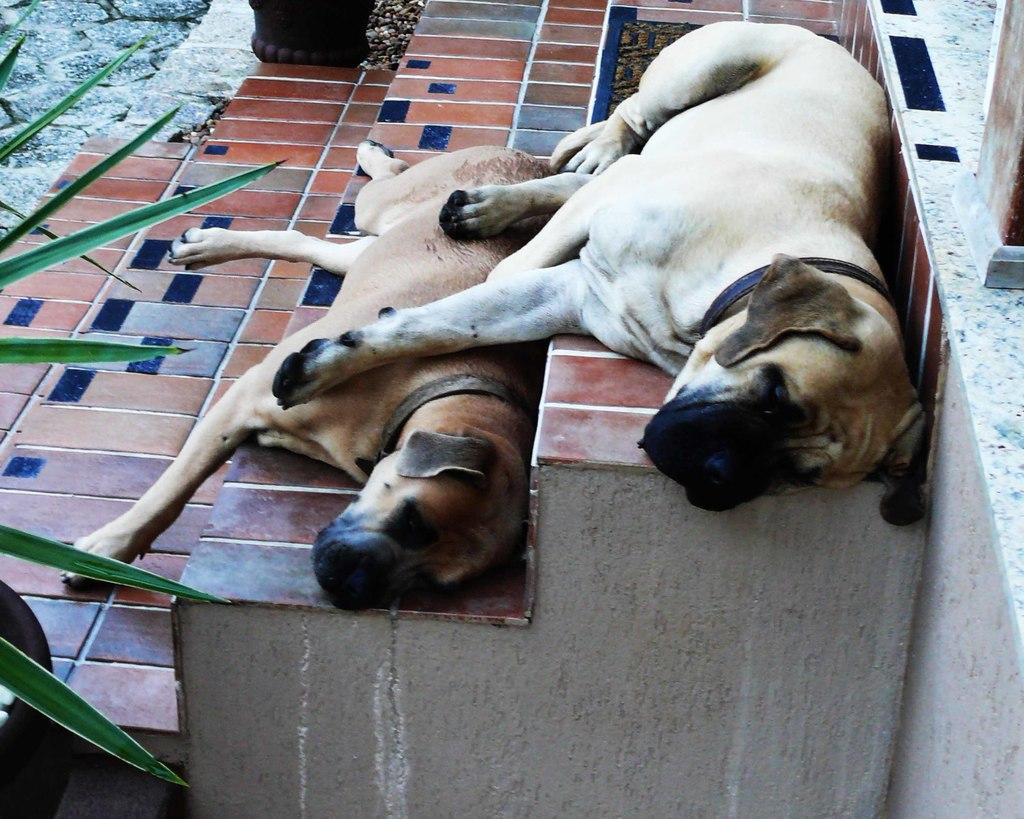What animals are lying on the steps in the image? There are dogs lying on the steps in the image. What type of vegetation can be seen in the image? Leaves are present in the image. What objects are visible in the image that might be used for holding plants? There are pots in the image. What type of structure is visible in the background of the image? There is a wall in the image. What type of trade is happening in the image? There is no trade happening in the image; it features dogs lying on steps, leaves, pots, and a wall. What type of yam can be seen growing near the wall in the image? There is no yam present in the image; it features dogs lying on steps, leaves, pots, and a wall. 